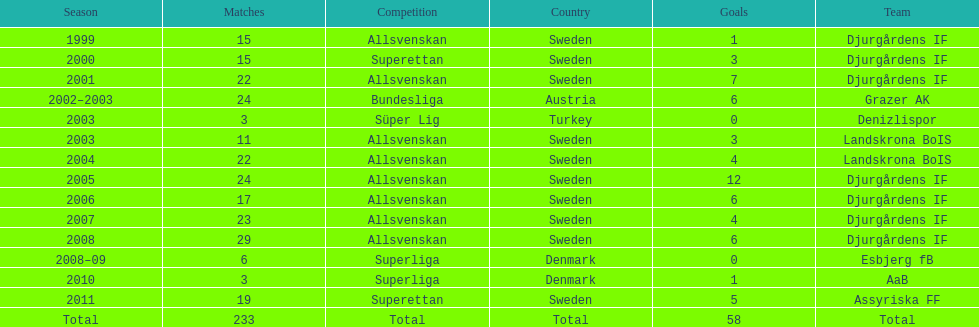Which season witnesses the highest number of goals? 2005. 